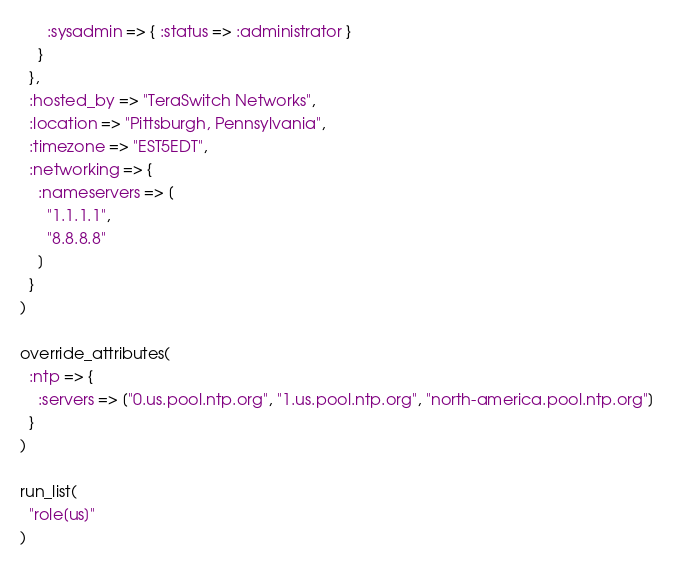Convert code to text. <code><loc_0><loc_0><loc_500><loc_500><_Ruby_>      :sysadmin => { :status => :administrator }
    }
  },
  :hosted_by => "TeraSwitch Networks",
  :location => "Pittsburgh, Pennsylvania",
  :timezone => "EST5EDT",
  :networking => {
    :nameservers => [
      "1.1.1.1",
      "8.8.8.8"
    ]
  }
)

override_attributes(
  :ntp => {
    :servers => ["0.us.pool.ntp.org", "1.us.pool.ntp.org", "north-america.pool.ntp.org"]
  }
)

run_list(
  "role[us]"
)
</code> 